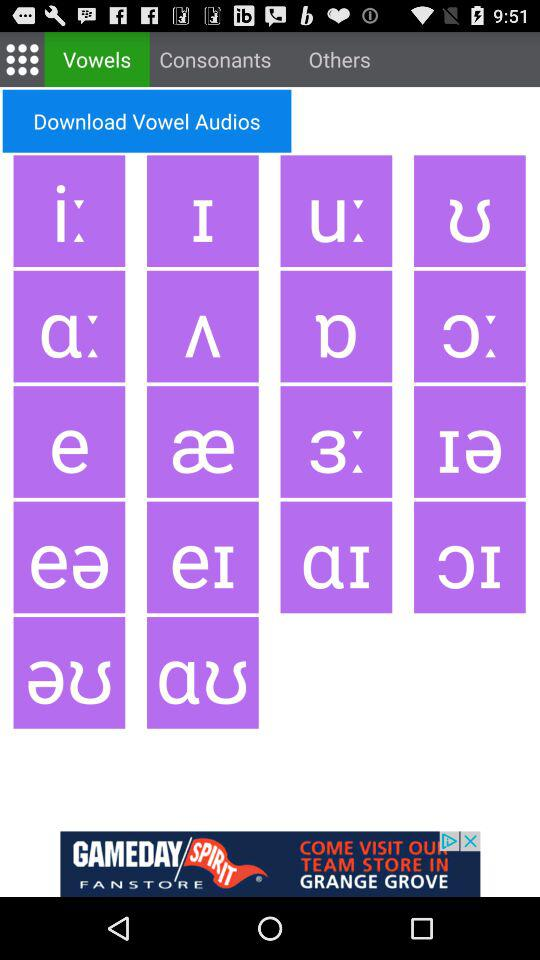Which tab is selected? The selected tab is "Vowels". 